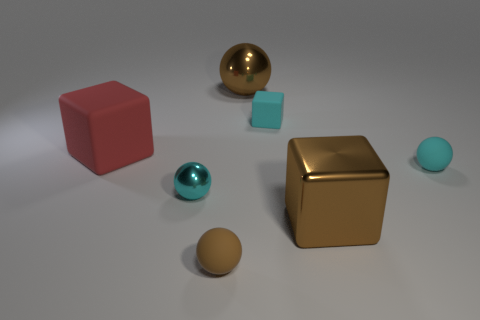Subtract 1 spheres. How many spheres are left? 3 Subtract all gray balls. Subtract all red blocks. How many balls are left? 4 Add 2 metal things. How many objects exist? 9 Subtract all cubes. How many objects are left? 4 Add 2 big brown metallic cubes. How many big brown metallic cubes are left? 3 Add 7 big yellow shiny things. How many big yellow shiny things exist? 7 Subtract 0 green cubes. How many objects are left? 7 Subtract all small blue matte blocks. Subtract all rubber blocks. How many objects are left? 5 